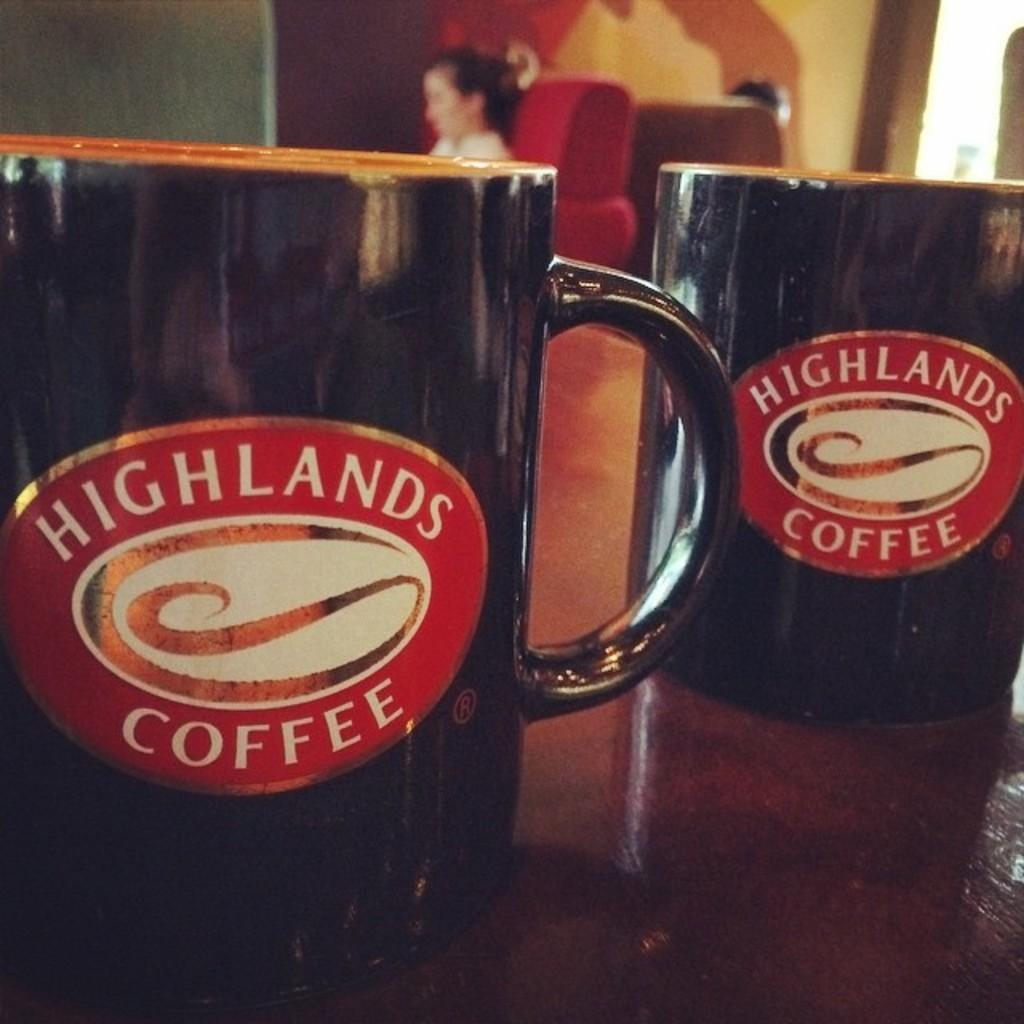Provide a one-sentence caption for the provided image. a cup that says Highlands Coffee on uit. 